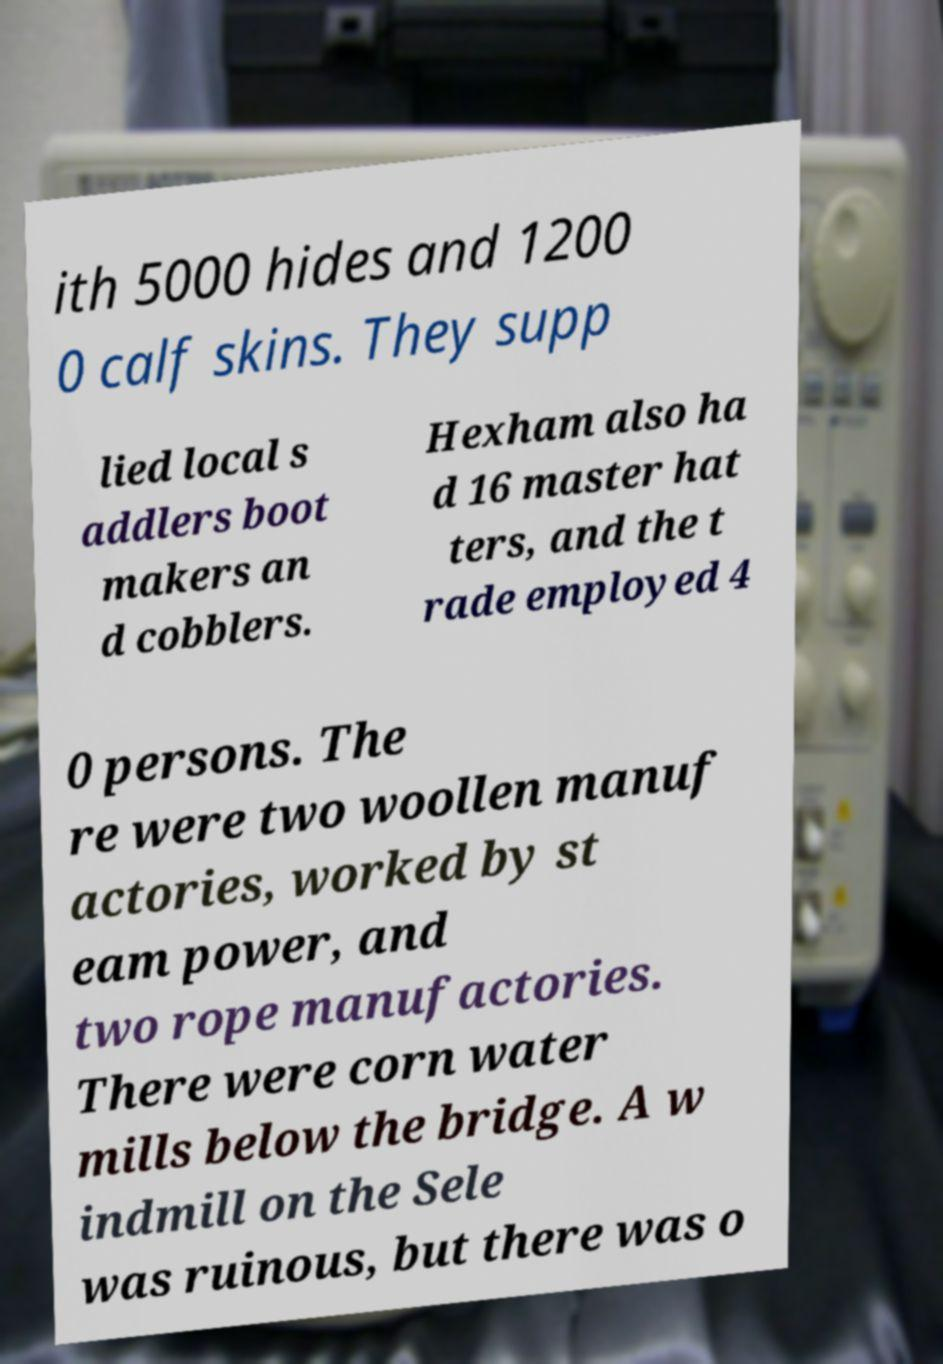Please identify and transcribe the text found in this image. ith 5000 hides and 1200 0 calf skins. They supp lied local s addlers boot makers an d cobblers. Hexham also ha d 16 master hat ters, and the t rade employed 4 0 persons. The re were two woollen manuf actories, worked by st eam power, and two rope manufactories. There were corn water mills below the bridge. A w indmill on the Sele was ruinous, but there was o 